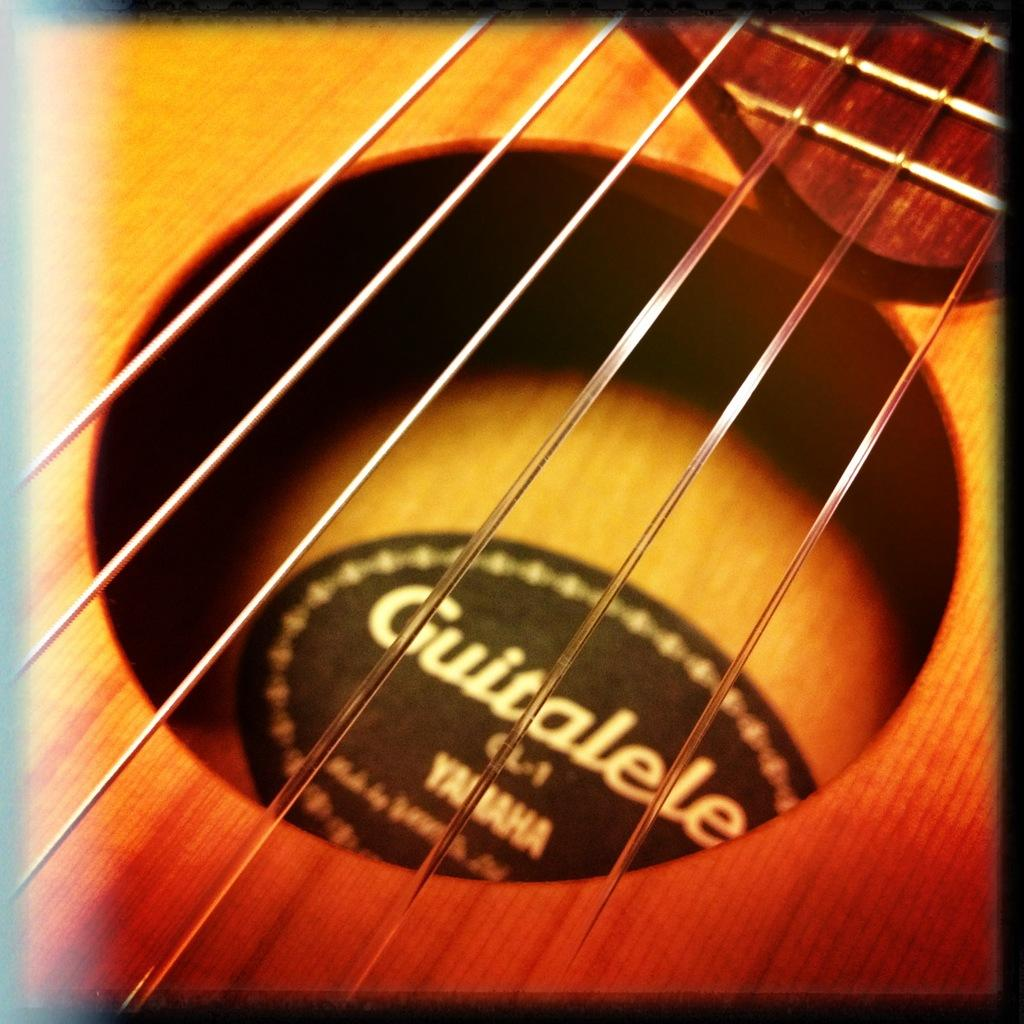What musical instrument is featured in the image? There are strings of a guitar in the image. Can you describe the main component of the guitar that is visible? The strings of the guitar are visible in the image. What type of suit is the guitar wearing in the image? The guitar is not wearing a suit, as it is an inanimate object and does not have the ability to wear clothing. 